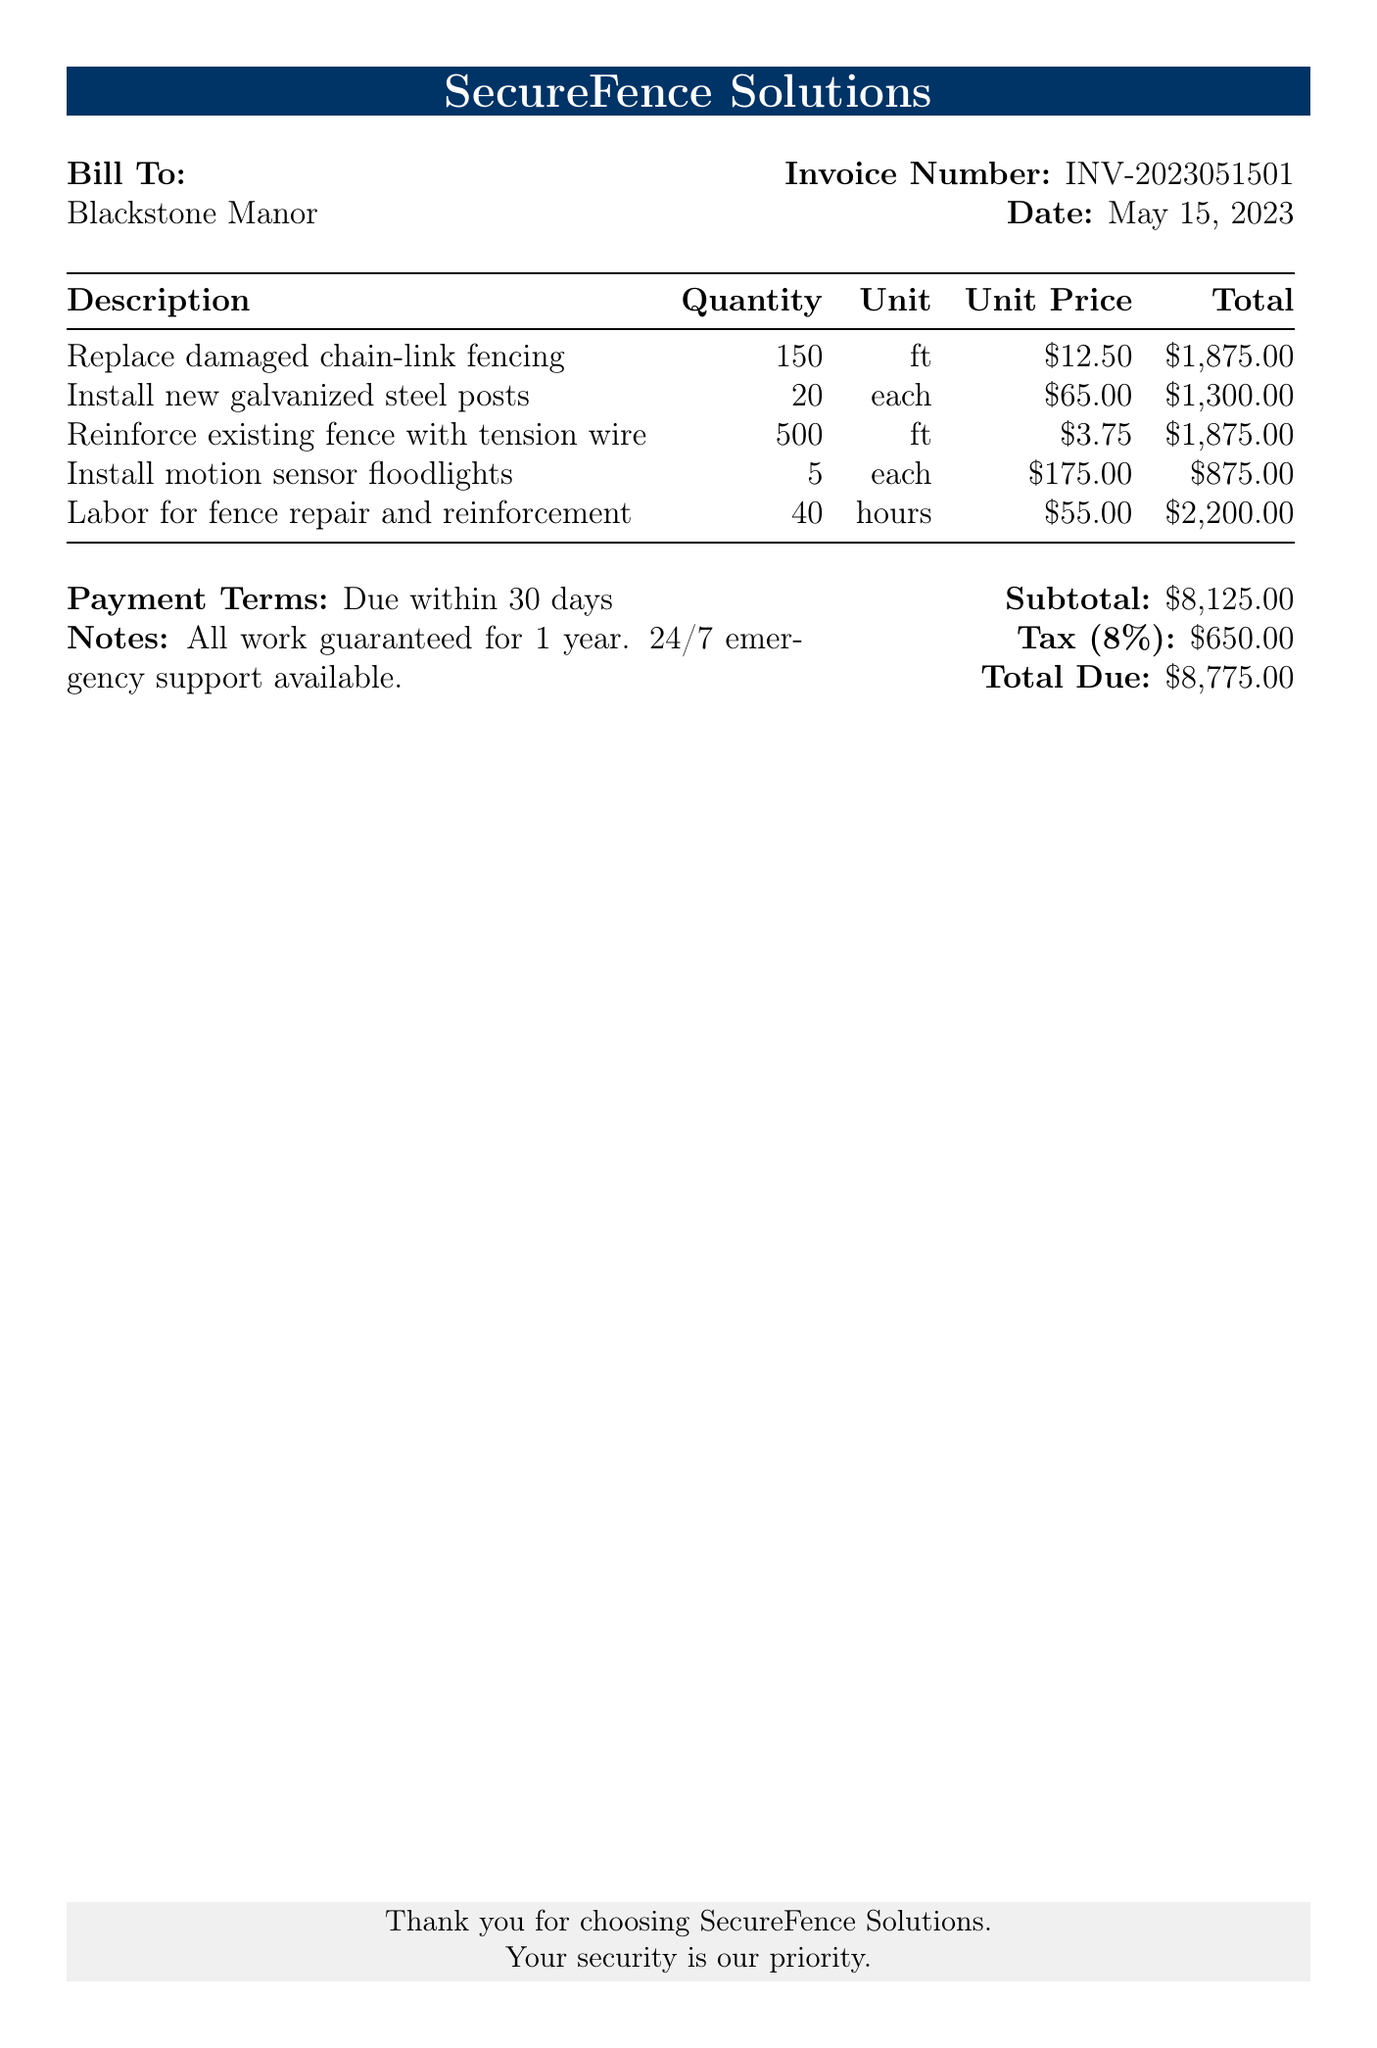What is the invoice number? The invoice number is listed in the document under the title "Invoice Number".
Answer: INV-2023051501 What is the date of the bill? The date is provided next to the invoice number.
Answer: May 15, 2023 What is the total due amount? The total due amount is stated at the bottom of the bill under "Total Due".
Answer: $8,775.00 How many feet of damaged chain-link fencing were replaced? The quantity of the damaged chain-link fencing replaced is in the first row of the description table.
Answer: 150 ft What is the subtotal before tax? The subtotal is listed separately before the tax amount in the financial summary section.
Answer: $8,125.00 How much is the labor cost for fence repair and reinforcement? The labor cost is specified in the last row of the description table.
Answer: $2,200.00 What is the tax percentage applied? The tax percentage is mentioned as part of the financial summary section of the document.
Answer: 8% What type of posts were installed? The type of posts is defined in the second row of the description table.
Answer: galvanized steel How many motion sensor floodlights were installed? The number of floodlights installed is noted in the fourth row of the description table.
Answer: 5 each 